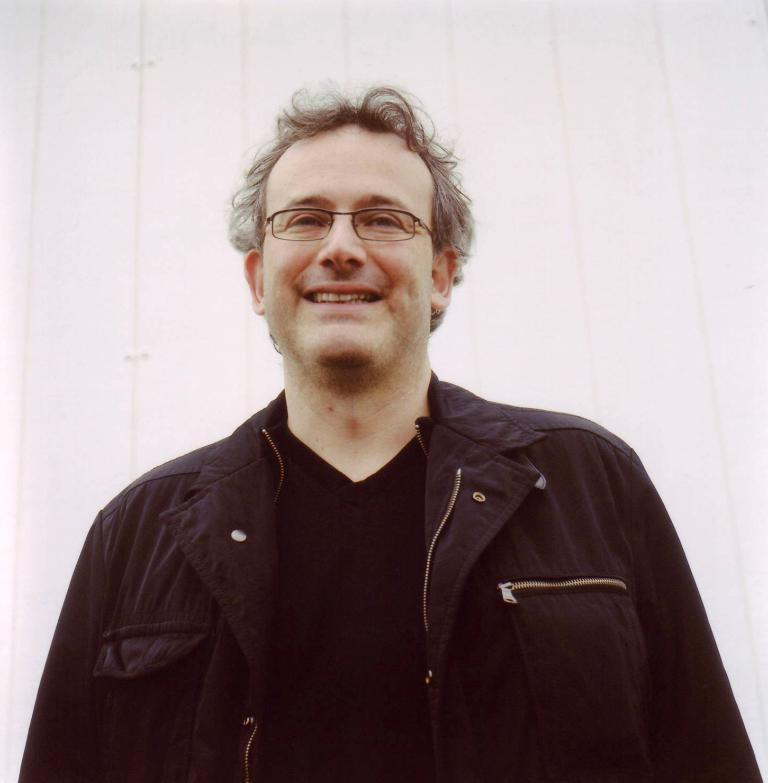What is the main subject of the image? There is a person in the image. Can you describe the person's appearance? The person is wearing spectacles. How much was the payment for the spectacles in the image? There is no information about payment in the image, as it only shows a person wearing spectacles. 